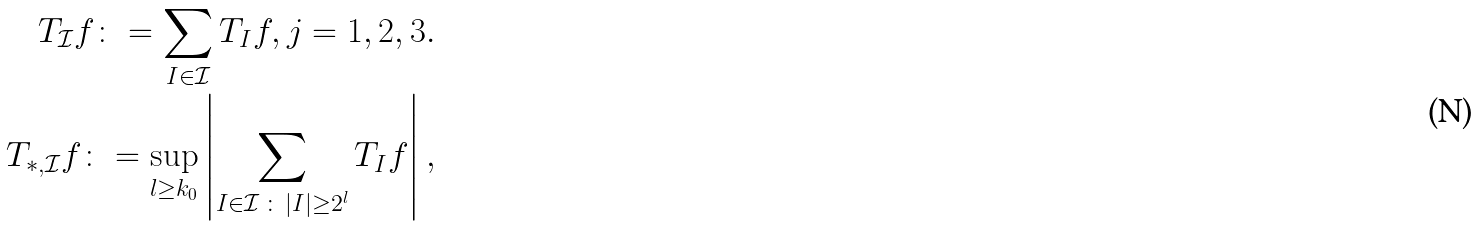Convert formula to latex. <formula><loc_0><loc_0><loc_500><loc_500>T _ { \mathcal { I } } f \colon = \sum _ { I \in \mathcal { I } } T _ { I } f , j = 1 , 2 , 3 . \\ T _ { \ast , \mathcal { I } } f \colon = \sup _ { l \geq k _ { 0 } } \left | \sum _ { I \in \mathcal { I } \, \colon \, | I | \geq 2 ^ { l } } T _ { I } f \right | ,</formula> 